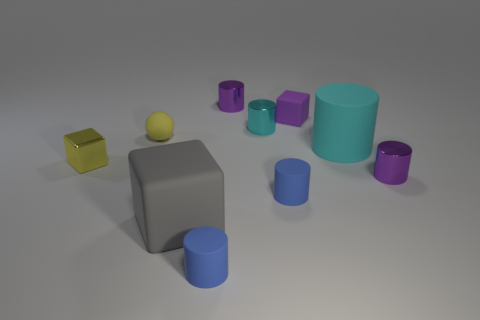Subtract 1 cylinders. How many cylinders are left? 5 Subtract all blue cylinders. How many cylinders are left? 4 Subtract all small matte cylinders. How many cylinders are left? 4 Subtract all gray cylinders. Subtract all green balls. How many cylinders are left? 6 Subtract all cylinders. How many objects are left? 4 Subtract 0 cyan balls. How many objects are left? 10 Subtract all big cylinders. Subtract all large yellow spheres. How many objects are left? 9 Add 1 rubber cylinders. How many rubber cylinders are left? 4 Add 3 tiny yellow things. How many tiny yellow things exist? 5 